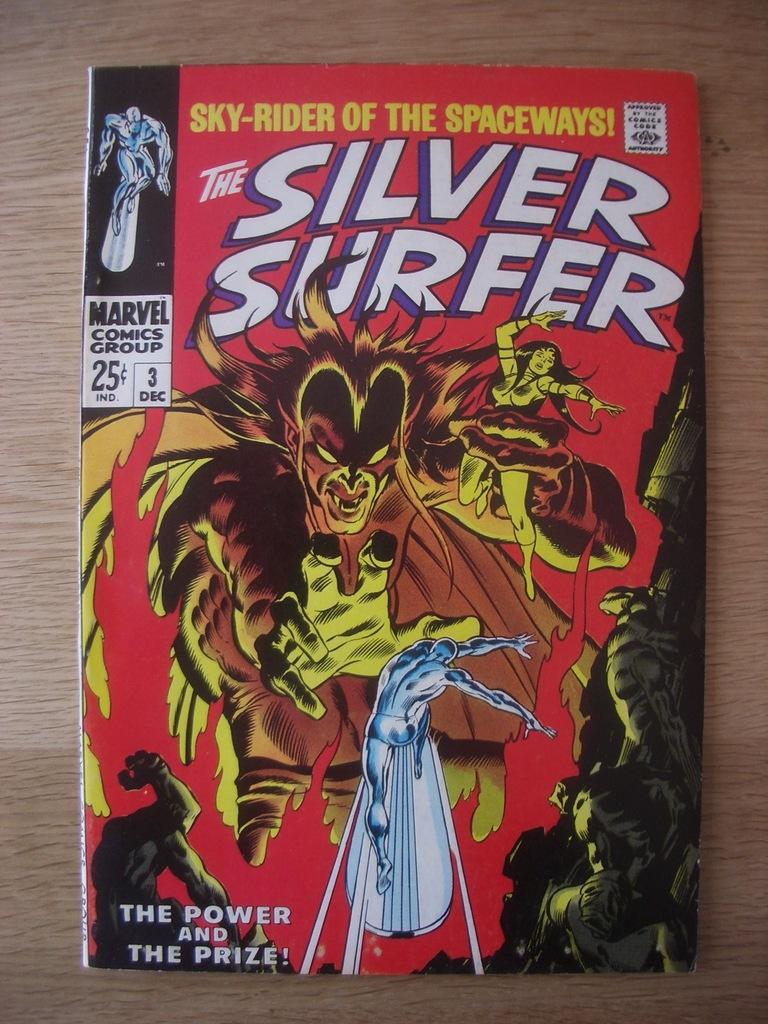<image>
Relay a brief, clear account of the picture shown. A comic book with the title The Silver Surfer with a creature holding a woman in the air on the cover. 